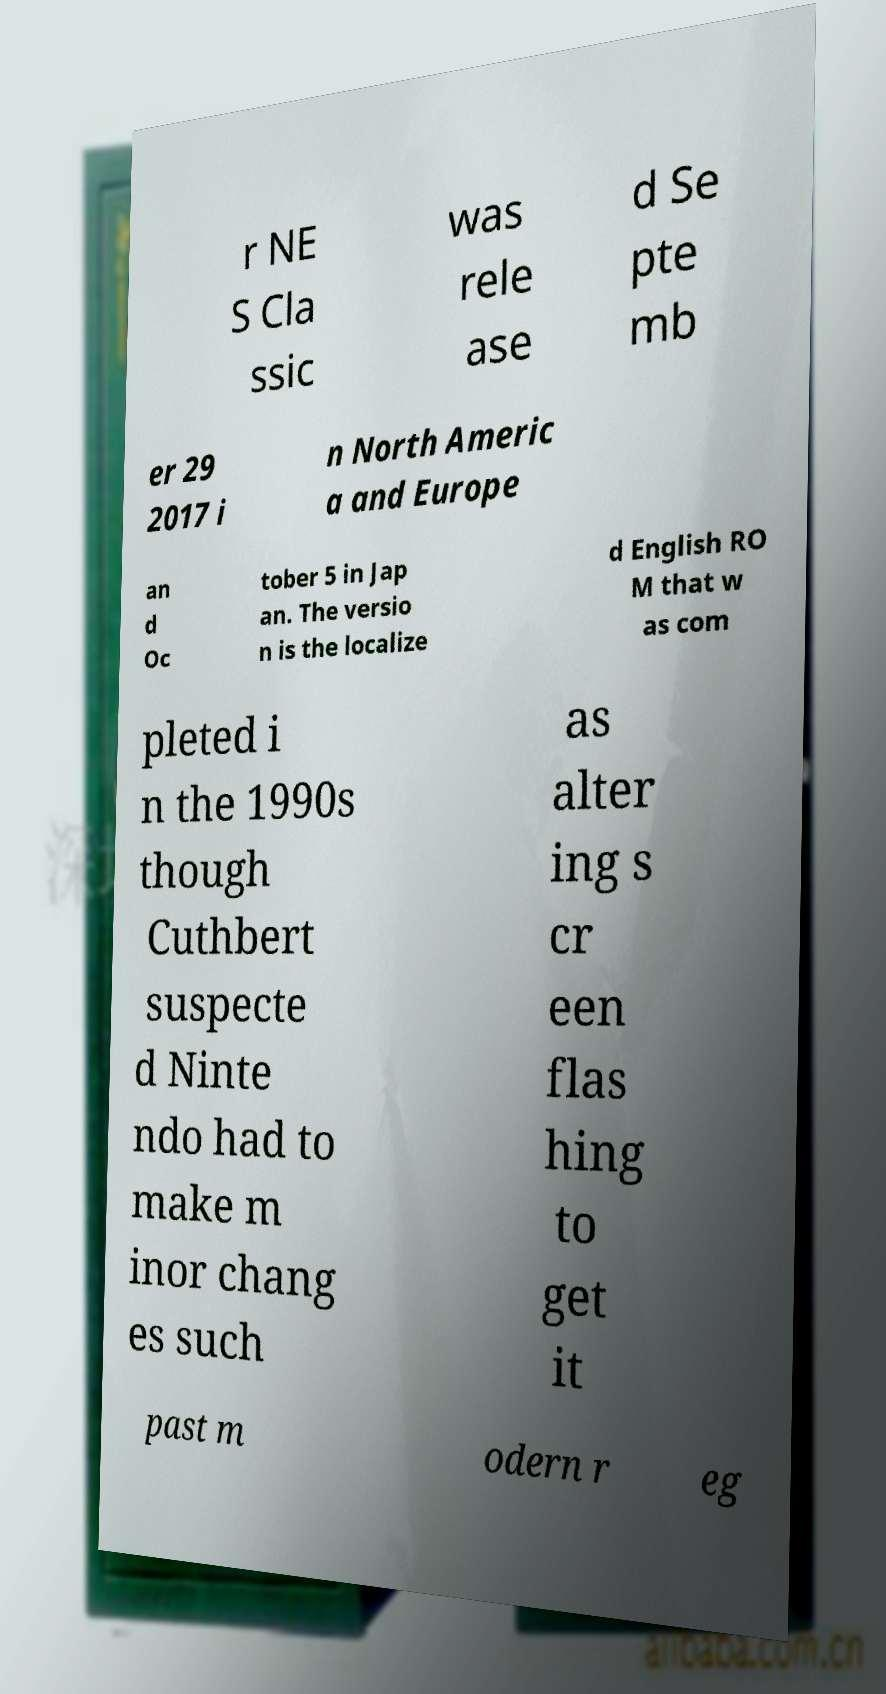Can you read and provide the text displayed in the image?This photo seems to have some interesting text. Can you extract and type it out for me? r NE S Cla ssic was rele ase d Se pte mb er 29 2017 i n North Americ a and Europe an d Oc tober 5 in Jap an. The versio n is the localize d English RO M that w as com pleted i n the 1990s though Cuthbert suspecte d Ninte ndo had to make m inor chang es such as alter ing s cr een flas hing to get it past m odern r eg 